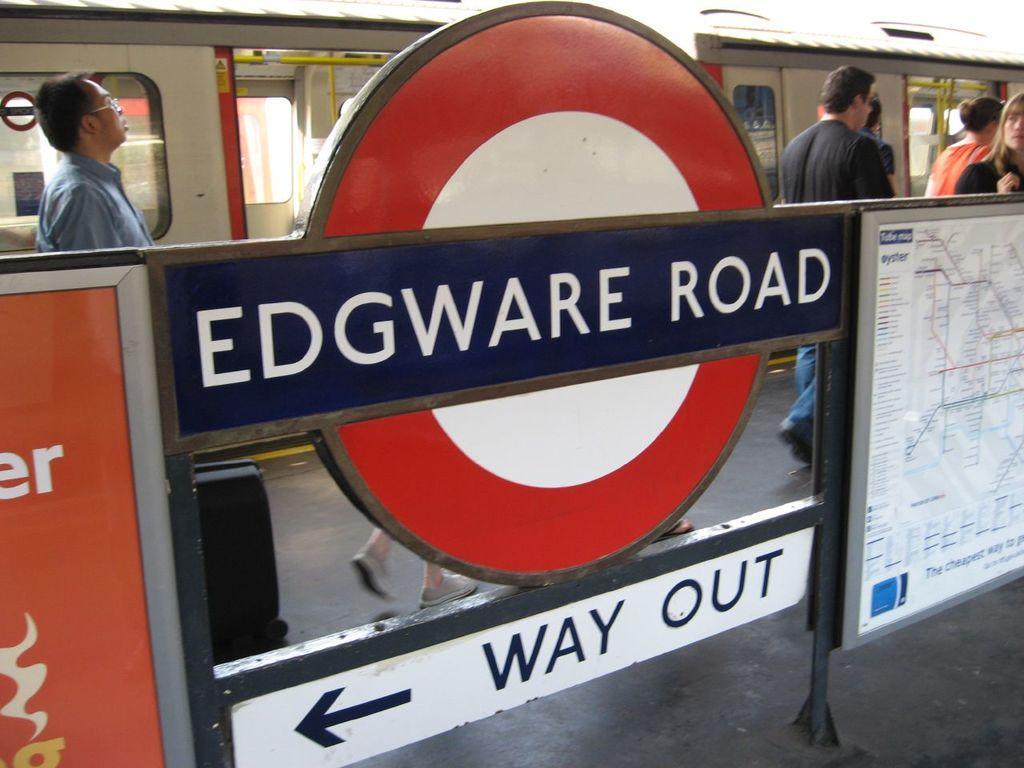In one or two sentences, can you explain what this image depicts? In this image I can see people and a train. Here I can see a board, on the board I can see a map and something written on it. 